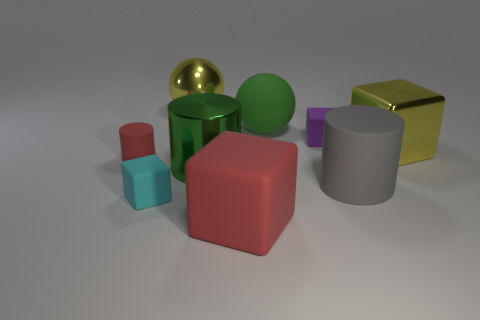What number of red things are either large metallic spheres or small rubber cylinders?
Give a very brief answer. 1. How many other things are the same shape as the purple rubber object?
Offer a very short reply. 3. What is the shape of the matte object that is both in front of the gray object and right of the tiny cyan matte thing?
Give a very brief answer. Cube. There is a large yellow block; are there any large matte cylinders behind it?
Make the answer very short. No. There is a red object that is the same shape as the big green metallic object; what size is it?
Give a very brief answer. Small. Is the big gray matte object the same shape as the cyan object?
Keep it short and to the point. No. What size is the block that is behind the yellow object that is on the right side of the big gray rubber thing?
Ensure brevity in your answer.  Small. There is a large rubber thing that is the same shape as the tiny red rubber thing; what is its color?
Your answer should be compact. Gray. What number of other spheres have the same color as the big rubber sphere?
Your response must be concise. 0. What size is the purple object?
Give a very brief answer. Small. 